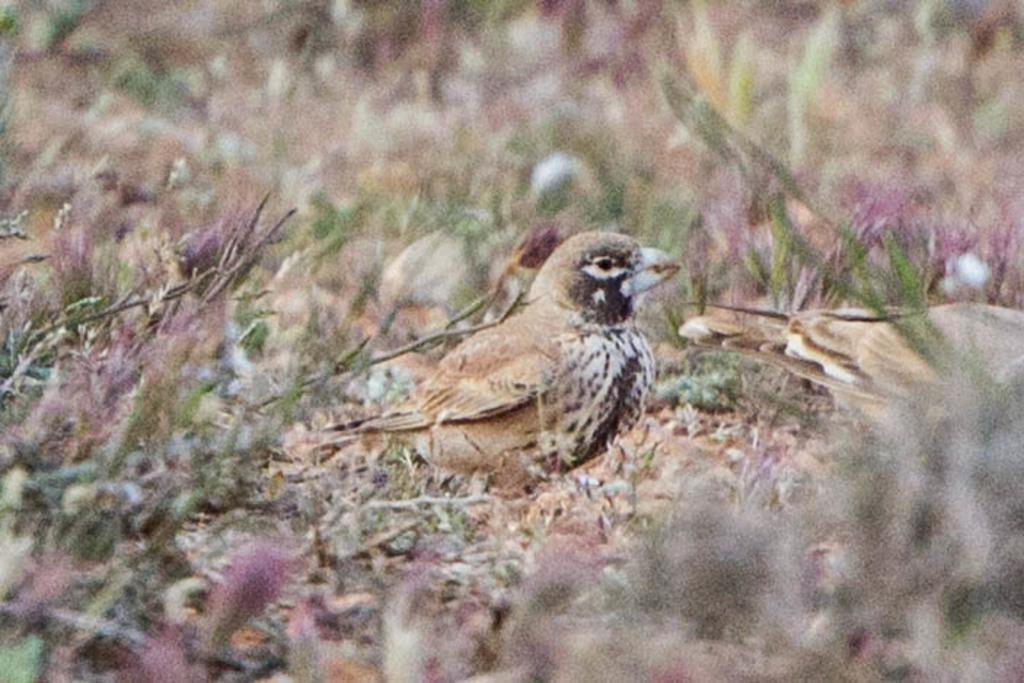Please provide a concise description of this image. At the bottom of the image there is grass. In the middle of the image there is a bird. 